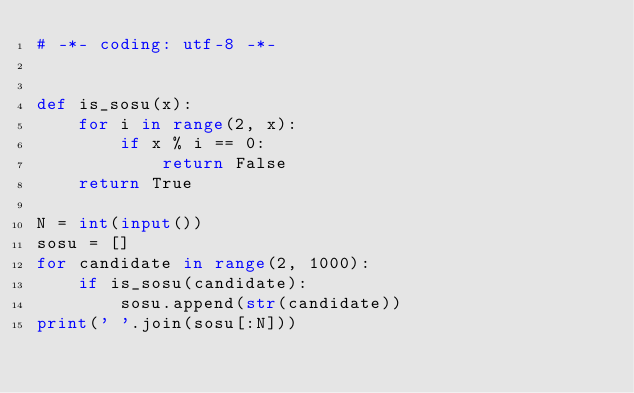<code> <loc_0><loc_0><loc_500><loc_500><_Python_># -*- coding: utf-8 -*-


def is_sosu(x):
    for i in range(2, x):
        if x % i == 0:
            return False
    return True

N = int(input())
sosu = []
for candidate in range(2, 1000):
    if is_sosu(candidate):
        sosu.append(str(candidate))
print(' '.join(sosu[:N]))
</code> 